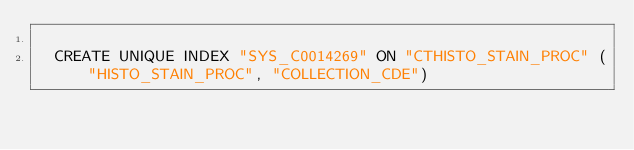<code> <loc_0><loc_0><loc_500><loc_500><_SQL_>
  CREATE UNIQUE INDEX "SYS_C0014269" ON "CTHISTO_STAIN_PROC" ("HISTO_STAIN_PROC", "COLLECTION_CDE") 
  </code> 